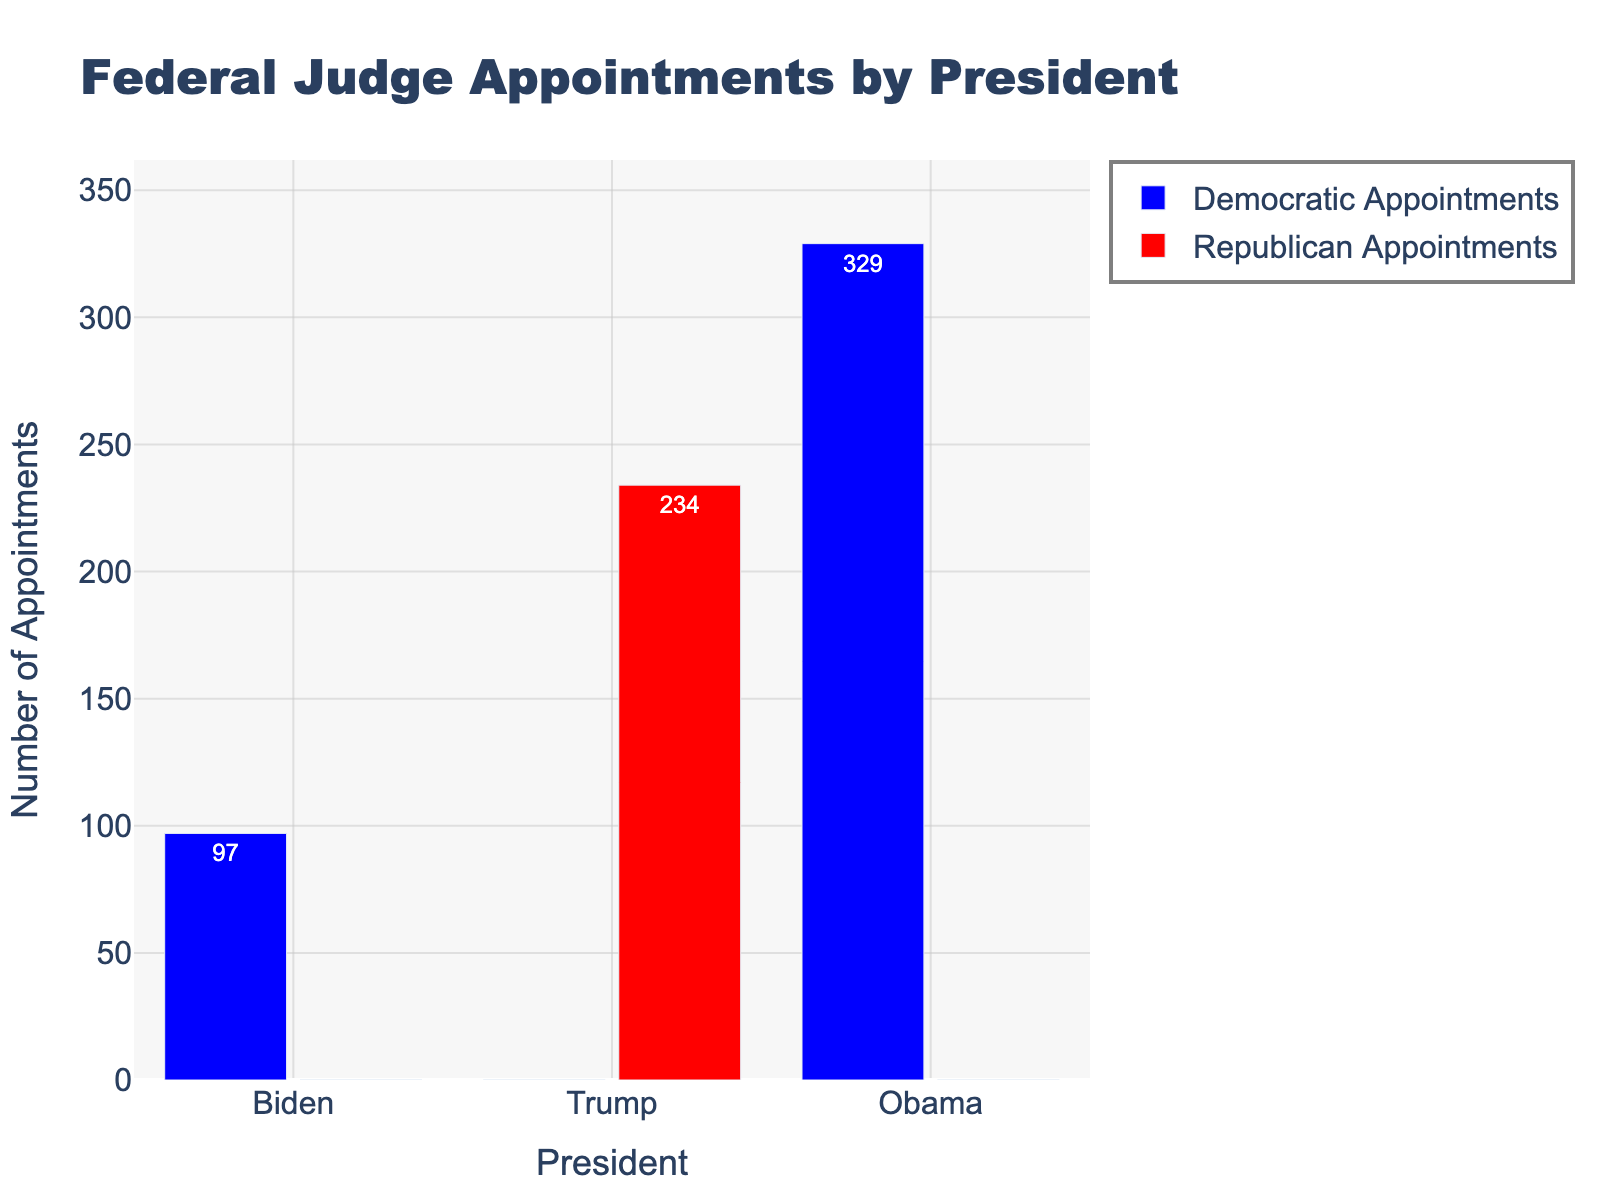What is the total number of Democratic Appointments made across all three Presidents? To find the total number of Democratic Appointments, sum the Democratic Appointments made by Biden, Trump, and Obama: 97 (Biden) + 0 (Trump) + 329 (Obama) = 426
Answer: 426 Who made the most Republican Appointments, and how many did they make? The bar for Republican Appointments is highest for Trump at 234 appointments, indicating he made the most Republican Appointments.
Answer: Trump, 234 Compare the number of total appointments by each President. Which President made the most total appointments? Calculate the total appointments by adding Democratic and Republican appointments for each President: 
Biden: 97 (Democratic) + 0 (Republican) = 97 
Trump: 0 (Democratic) + 234 (Republican) = 234 
Obama: 329 (Democratic) + 0 (Republican) = 329 
Obama made the most total appointments with 329.
Answer: Obama, 329 What is the difference in the number of Democratic Appointments made by Obama and Biden? Subtract the number of Democratic Appointments made by Biden from those made by Obama: 329 (Obama) - 97 (Biden) = 232
Answer: 232 Which President has appointments only from one political party? The chart shows that Biden and Obama have only Democratic Appointments (blue bars), and Trump has only Republican Appointments (red bar).
Answer: Biden, Obama, Trump How many more Republican Appointments did Trump make than the combined Democratic Appointments made by Biden and Trump? Calculate the combined Democratic appointments made by Biden and Trump: 97 (Biden) + 0 (Trump) = 97. Subtract this sum from the number of Republican Appointments by Trump: 234 - 97 = 137
Answer: 137 What percentage of Obama's appointments were Democratic Appointments? Since Obama made 329 total appointments and all were Democratic Appointments, the percentage is: (329 / 329) * 100% = 100%
Answer: 100% By looking at the colors, which political party has been more favored in appointments during Biden's presidency? Since Biden’s presidency has only blue bars representing Democratic Appointments, it indicates that the Democratic Party has been more favored during his presidency.
Answer: Democratic Party 